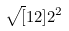Convert formula to latex. <formula><loc_0><loc_0><loc_500><loc_500>\sqrt { [ } 1 2 ] { 2 ^ { 2 } }</formula> 